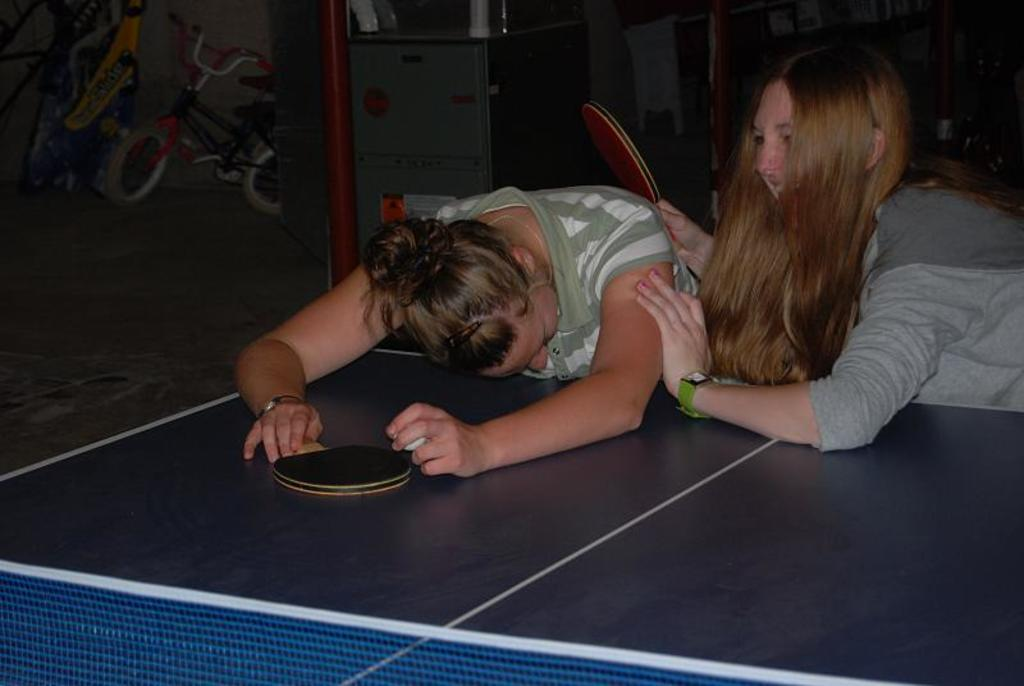How many people are in the image? There are two women in the image. What are the women holding in the image? The women are holding table tennis bats. What object is present that is typically used for playing table tennis? There is a table tennis table in the image. What type of verse can be heard being recited by the women in the image? There is no indication in the image that the women are reciting any verses. 